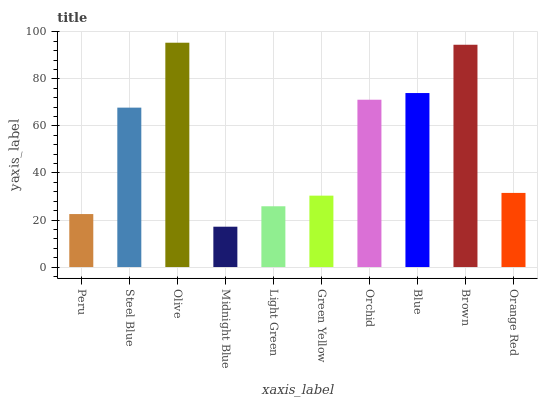Is Midnight Blue the minimum?
Answer yes or no. Yes. Is Olive the maximum?
Answer yes or no. Yes. Is Steel Blue the minimum?
Answer yes or no. No. Is Steel Blue the maximum?
Answer yes or no. No. Is Steel Blue greater than Peru?
Answer yes or no. Yes. Is Peru less than Steel Blue?
Answer yes or no. Yes. Is Peru greater than Steel Blue?
Answer yes or no. No. Is Steel Blue less than Peru?
Answer yes or no. No. Is Steel Blue the high median?
Answer yes or no. Yes. Is Orange Red the low median?
Answer yes or no. Yes. Is Orange Red the high median?
Answer yes or no. No. Is Blue the low median?
Answer yes or no. No. 